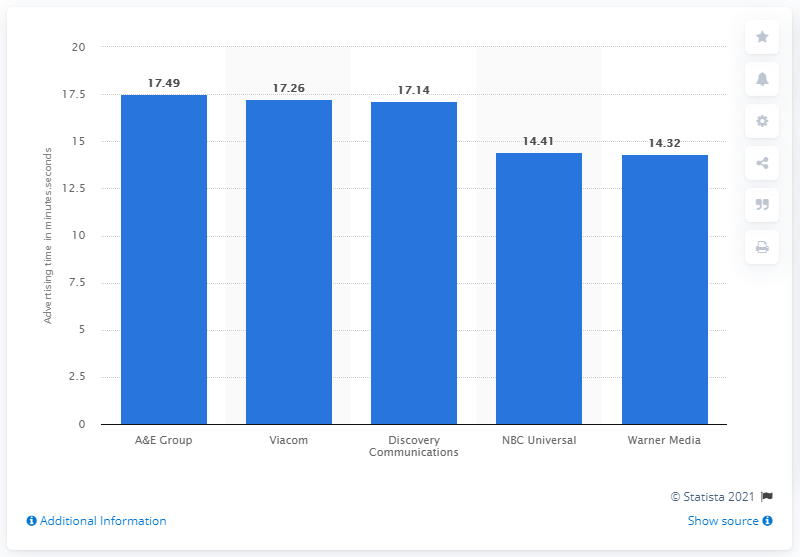Outline some significant characteristics in this image. According to the information, Warner Media was the cable network group that had an average of 14 minutes and 32 seconds of ad time per primetime hour. 